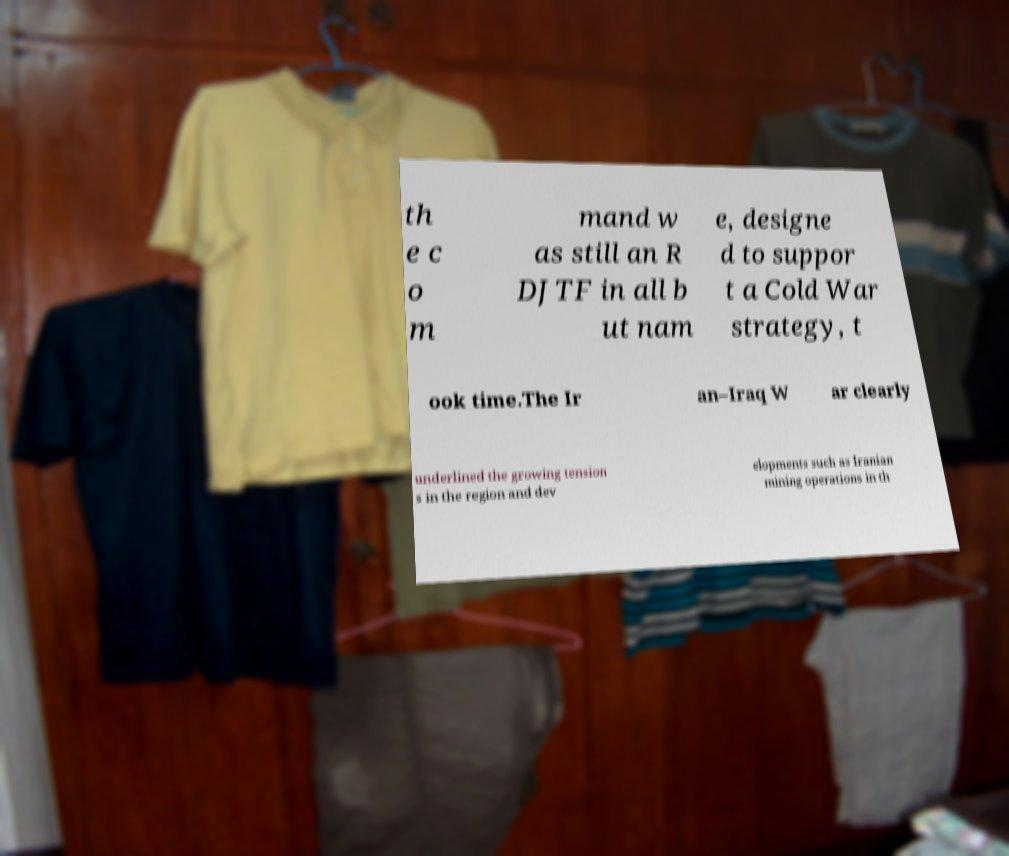There's text embedded in this image that I need extracted. Can you transcribe it verbatim? th e c o m mand w as still an R DJTF in all b ut nam e, designe d to suppor t a Cold War strategy, t ook time.The Ir an–Iraq W ar clearly underlined the growing tension s in the region and dev elopments such as Iranian mining operations in th 